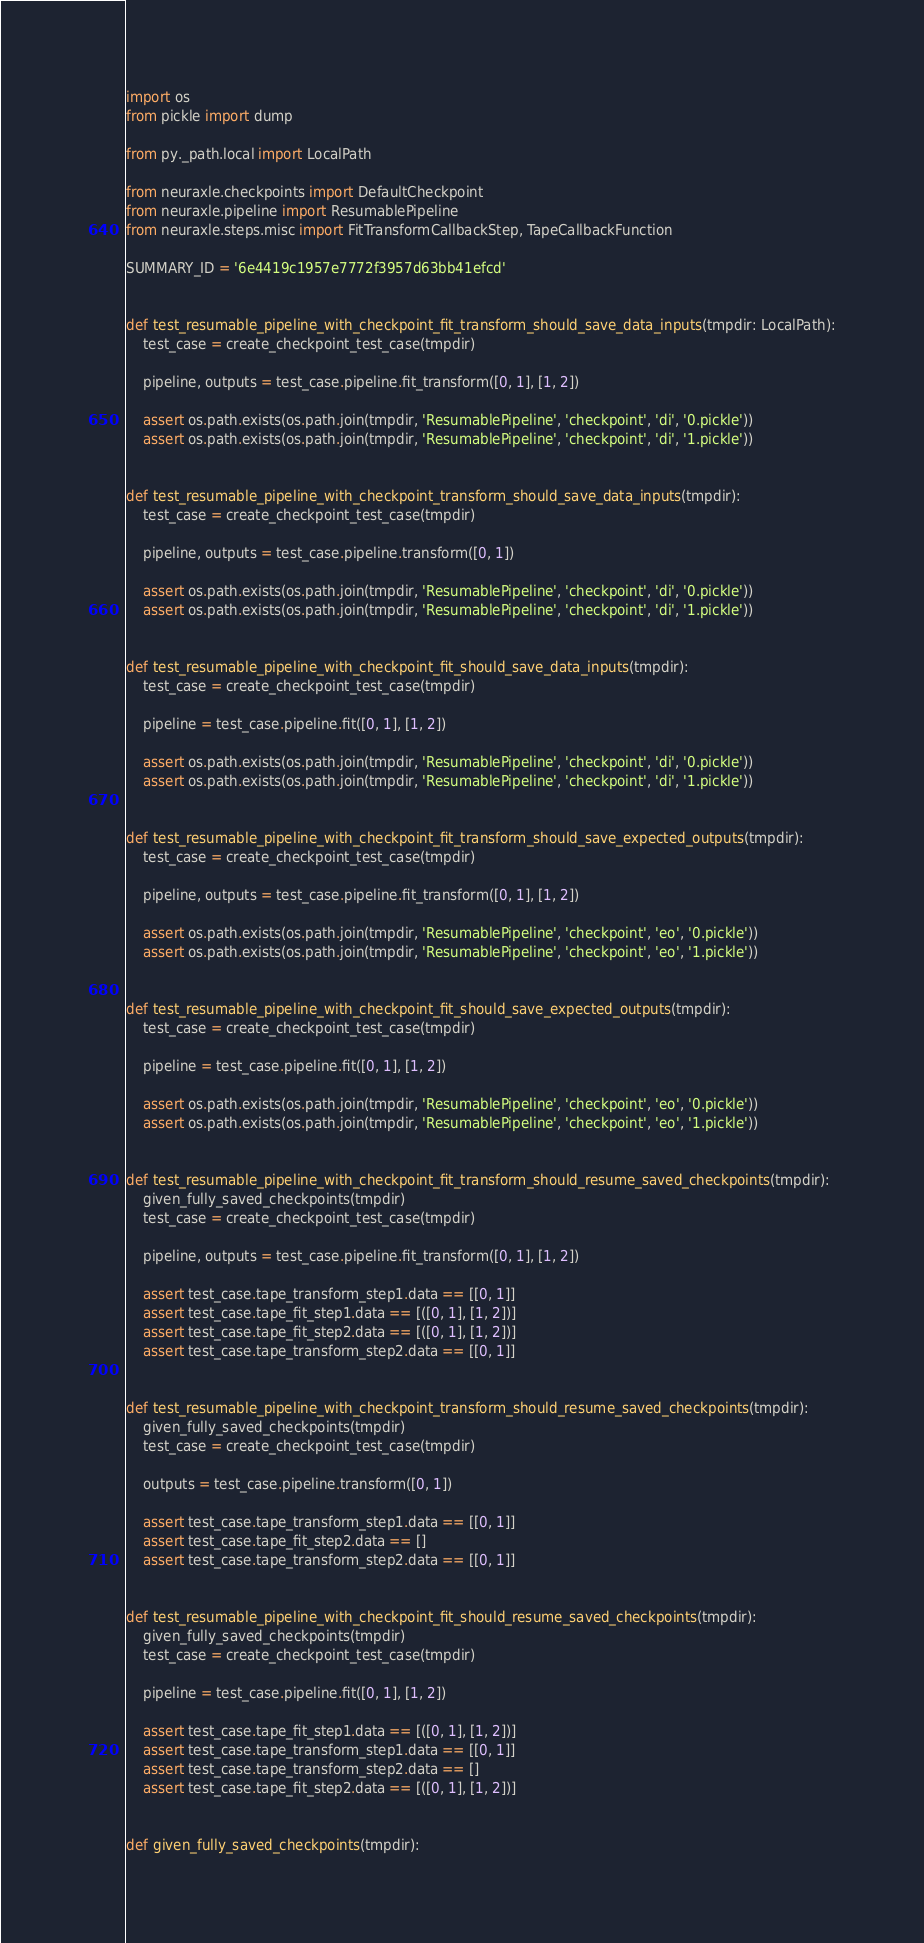Convert code to text. <code><loc_0><loc_0><loc_500><loc_500><_Python_>import os
from pickle import dump

from py._path.local import LocalPath

from neuraxle.checkpoints import DefaultCheckpoint
from neuraxle.pipeline import ResumablePipeline
from neuraxle.steps.misc import FitTransformCallbackStep, TapeCallbackFunction

SUMMARY_ID = '6e4419c1957e7772f3957d63bb41efcd'


def test_resumable_pipeline_with_checkpoint_fit_transform_should_save_data_inputs(tmpdir: LocalPath):
    test_case = create_checkpoint_test_case(tmpdir)

    pipeline, outputs = test_case.pipeline.fit_transform([0, 1], [1, 2])

    assert os.path.exists(os.path.join(tmpdir, 'ResumablePipeline', 'checkpoint', 'di', '0.pickle'))
    assert os.path.exists(os.path.join(tmpdir, 'ResumablePipeline', 'checkpoint', 'di', '1.pickle'))


def test_resumable_pipeline_with_checkpoint_transform_should_save_data_inputs(tmpdir):
    test_case = create_checkpoint_test_case(tmpdir)

    pipeline, outputs = test_case.pipeline.transform([0, 1])

    assert os.path.exists(os.path.join(tmpdir, 'ResumablePipeline', 'checkpoint', 'di', '0.pickle'))
    assert os.path.exists(os.path.join(tmpdir, 'ResumablePipeline', 'checkpoint', 'di', '1.pickle'))


def test_resumable_pipeline_with_checkpoint_fit_should_save_data_inputs(tmpdir):
    test_case = create_checkpoint_test_case(tmpdir)

    pipeline = test_case.pipeline.fit([0, 1], [1, 2])

    assert os.path.exists(os.path.join(tmpdir, 'ResumablePipeline', 'checkpoint', 'di', '0.pickle'))
    assert os.path.exists(os.path.join(tmpdir, 'ResumablePipeline', 'checkpoint', 'di', '1.pickle'))


def test_resumable_pipeline_with_checkpoint_fit_transform_should_save_expected_outputs(tmpdir):
    test_case = create_checkpoint_test_case(tmpdir)

    pipeline, outputs = test_case.pipeline.fit_transform([0, 1], [1, 2])

    assert os.path.exists(os.path.join(tmpdir, 'ResumablePipeline', 'checkpoint', 'eo', '0.pickle'))
    assert os.path.exists(os.path.join(tmpdir, 'ResumablePipeline', 'checkpoint', 'eo', '1.pickle'))


def test_resumable_pipeline_with_checkpoint_fit_should_save_expected_outputs(tmpdir):
    test_case = create_checkpoint_test_case(tmpdir)

    pipeline = test_case.pipeline.fit([0, 1], [1, 2])

    assert os.path.exists(os.path.join(tmpdir, 'ResumablePipeline', 'checkpoint', 'eo', '0.pickle'))
    assert os.path.exists(os.path.join(tmpdir, 'ResumablePipeline', 'checkpoint', 'eo', '1.pickle'))


def test_resumable_pipeline_with_checkpoint_fit_transform_should_resume_saved_checkpoints(tmpdir):
    given_fully_saved_checkpoints(tmpdir)
    test_case = create_checkpoint_test_case(tmpdir)

    pipeline, outputs = test_case.pipeline.fit_transform([0, 1], [1, 2])

    assert test_case.tape_transform_step1.data == [[0, 1]]
    assert test_case.tape_fit_step1.data == [([0, 1], [1, 2])]
    assert test_case.tape_fit_step2.data == [([0, 1], [1, 2])]
    assert test_case.tape_transform_step2.data == [[0, 1]]


def test_resumable_pipeline_with_checkpoint_transform_should_resume_saved_checkpoints(tmpdir):
    given_fully_saved_checkpoints(tmpdir)
    test_case = create_checkpoint_test_case(tmpdir)

    outputs = test_case.pipeline.transform([0, 1])

    assert test_case.tape_transform_step1.data == [[0, 1]]
    assert test_case.tape_fit_step2.data == []
    assert test_case.tape_transform_step2.data == [[0, 1]]


def test_resumable_pipeline_with_checkpoint_fit_should_resume_saved_checkpoints(tmpdir):
    given_fully_saved_checkpoints(tmpdir)
    test_case = create_checkpoint_test_case(tmpdir)

    pipeline = test_case.pipeline.fit([0, 1], [1, 2])

    assert test_case.tape_fit_step1.data == [([0, 1], [1, 2])]
    assert test_case.tape_transform_step1.data == [[0, 1]]
    assert test_case.tape_transform_step2.data == []
    assert test_case.tape_fit_step2.data == [([0, 1], [1, 2])]


def given_fully_saved_checkpoints(tmpdir):</code> 